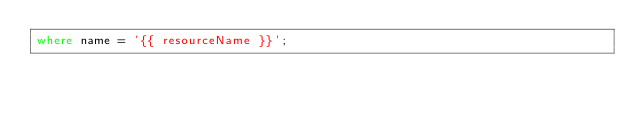Convert code to text. <code><loc_0><loc_0><loc_500><loc_500><_SQL_>where name = '{{ resourceName }}';</code> 